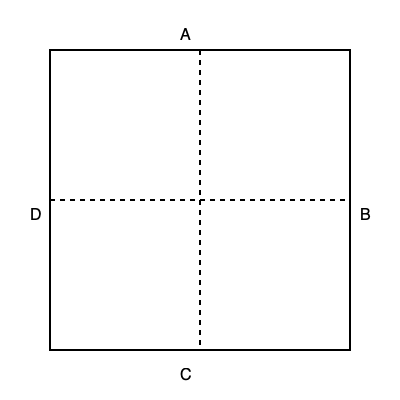As an auction enthusiast, you're tasked with folding a square auction catalog along its diagonals to create a triangular shape. If the catalog measures 12 inches on each side, what would be the length of the base of the resulting triangle when the catalog is folded in half diagonally? Let's approach this step-by-step:

1. The catalog is a square with sides of 12 inches.

2. When folded diagonally, it forms an isosceles right triangle.

3. The diagonal of the square becomes the hypotenuse of this triangle.

4. To find the length of the diagonal, we use the Pythagorean theorem:
   $a^2 + a^2 = c^2$, where $a$ is the side of the square and $c$ is the diagonal.

5. Substituting the values:
   $12^2 + 12^2 = c^2$
   $144 + 144 = c^2$
   $288 = c^2$

6. Taking the square root of both sides:
   $c = \sqrt{288} = 12\sqrt{2}$ inches

7. This diagonal (hypotenuse) becomes the base of the triangle when the catalog is folded in half diagonally.

Therefore, the length of the base of the resulting triangle is $12\sqrt{2}$ inches.
Answer: $12\sqrt{2}$ inches 